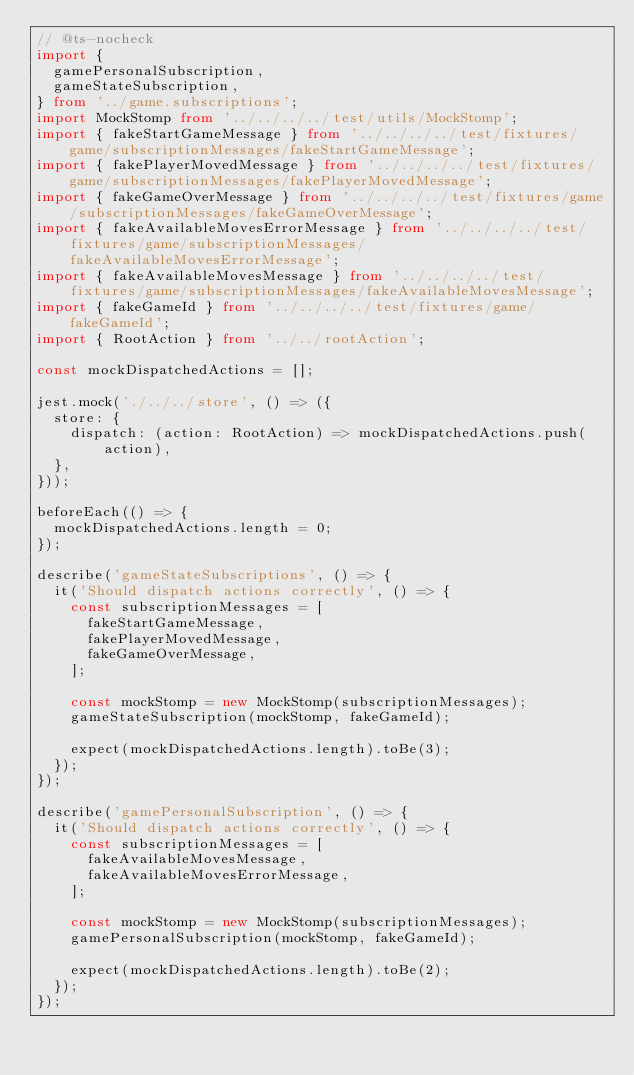<code> <loc_0><loc_0><loc_500><loc_500><_TypeScript_>// @ts-nocheck
import {
  gamePersonalSubscription,
  gameStateSubscription,
} from '../game.subscriptions';
import MockStomp from '../../../../test/utils/MockStomp';
import { fakeStartGameMessage } from '../../../../test/fixtures/game/subscriptionMessages/fakeStartGameMessage';
import { fakePlayerMovedMessage } from '../../../../test/fixtures/game/subscriptionMessages/fakePlayerMovedMessage';
import { fakeGameOverMessage } from '../../../../test/fixtures/game/subscriptionMessages/fakeGameOverMessage';
import { fakeAvailableMovesErrorMessage } from '../../../../test/fixtures/game/subscriptionMessages/fakeAvailableMovesErrorMessage';
import { fakeAvailableMovesMessage } from '../../../../test/fixtures/game/subscriptionMessages/fakeAvailableMovesMessage';
import { fakeGameId } from '../../../../test/fixtures/game/fakeGameId';
import { RootAction } from '../../rootAction';

const mockDispatchedActions = [];

jest.mock('./../../store', () => ({
  store: {
    dispatch: (action: RootAction) => mockDispatchedActions.push(action),
  },
}));

beforeEach(() => {
  mockDispatchedActions.length = 0;
});

describe('gameStateSubscriptions', () => {
  it('Should dispatch actions correctly', () => {
    const subscriptionMessages = [
      fakeStartGameMessage,
      fakePlayerMovedMessage,
      fakeGameOverMessage,
    ];

    const mockStomp = new MockStomp(subscriptionMessages);
    gameStateSubscription(mockStomp, fakeGameId);

    expect(mockDispatchedActions.length).toBe(3);
  });
});

describe('gamePersonalSubscription', () => {
  it('Should dispatch actions correctly', () => {
    const subscriptionMessages = [
      fakeAvailableMovesMessage,
      fakeAvailableMovesErrorMessage,
    ];

    const mockStomp = new MockStomp(subscriptionMessages);
    gamePersonalSubscription(mockStomp, fakeGameId);

    expect(mockDispatchedActions.length).toBe(2);
  });
});
</code> 